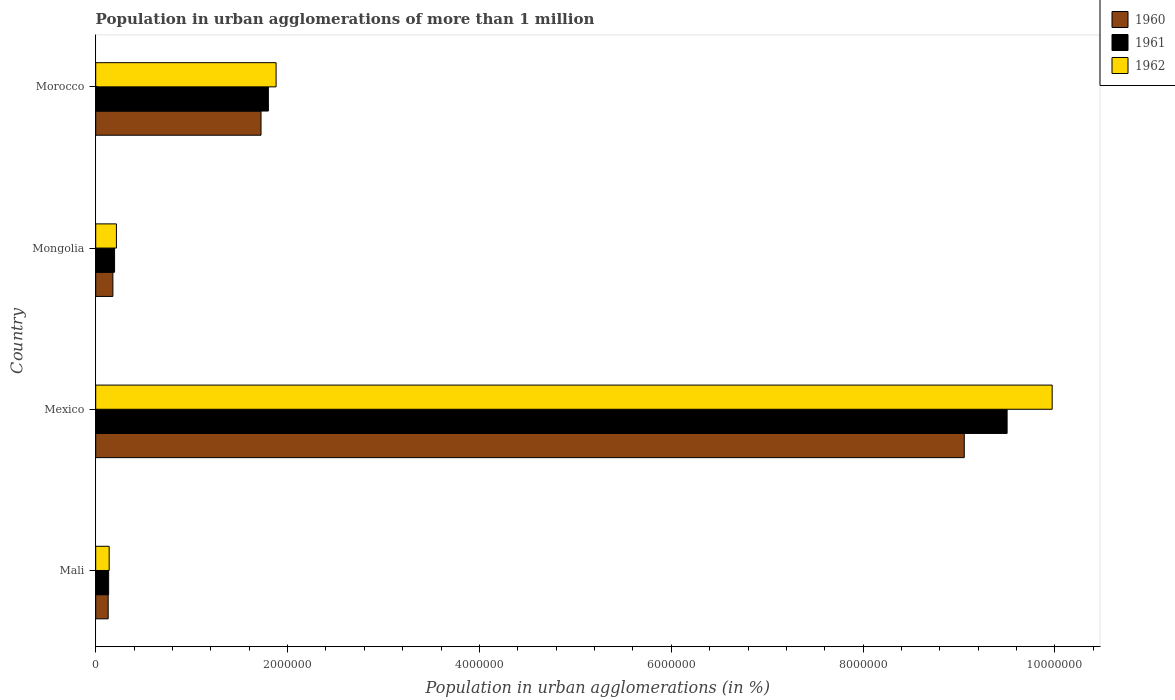How many different coloured bars are there?
Offer a very short reply. 3. How many groups of bars are there?
Your response must be concise. 4. How many bars are there on the 2nd tick from the top?
Offer a terse response. 3. How many bars are there on the 4th tick from the bottom?
Your answer should be very brief. 3. What is the label of the 1st group of bars from the top?
Offer a terse response. Morocco. In how many cases, is the number of bars for a given country not equal to the number of legend labels?
Your answer should be very brief. 0. What is the population in urban agglomerations in 1960 in Mexico?
Offer a terse response. 9.05e+06. Across all countries, what is the maximum population in urban agglomerations in 1960?
Offer a very short reply. 9.05e+06. Across all countries, what is the minimum population in urban agglomerations in 1962?
Your answer should be compact. 1.40e+05. In which country was the population in urban agglomerations in 1962 minimum?
Your response must be concise. Mali. What is the total population in urban agglomerations in 1961 in the graph?
Provide a succinct answer. 1.16e+07. What is the difference between the population in urban agglomerations in 1960 in Mexico and that in Mongolia?
Offer a terse response. 8.88e+06. What is the difference between the population in urban agglomerations in 1962 in Mongolia and the population in urban agglomerations in 1960 in Morocco?
Offer a very short reply. -1.51e+06. What is the average population in urban agglomerations in 1962 per country?
Your answer should be very brief. 3.05e+06. What is the difference between the population in urban agglomerations in 1961 and population in urban agglomerations in 1962 in Mexico?
Offer a terse response. -4.70e+05. What is the ratio of the population in urban agglomerations in 1961 in Mali to that in Mongolia?
Your answer should be compact. 0.69. What is the difference between the highest and the second highest population in urban agglomerations in 1962?
Provide a short and direct response. 8.09e+06. What is the difference between the highest and the lowest population in urban agglomerations in 1962?
Make the answer very short. 9.83e+06. What does the 2nd bar from the top in Mexico represents?
Your answer should be very brief. 1961. Is it the case that in every country, the sum of the population in urban agglomerations in 1961 and population in urban agglomerations in 1960 is greater than the population in urban agglomerations in 1962?
Provide a succinct answer. Yes. How many bars are there?
Your answer should be compact. 12. Are all the bars in the graph horizontal?
Offer a terse response. Yes. How many countries are there in the graph?
Provide a short and direct response. 4. Does the graph contain grids?
Provide a succinct answer. No. Where does the legend appear in the graph?
Your answer should be very brief. Top right. How are the legend labels stacked?
Provide a succinct answer. Vertical. What is the title of the graph?
Provide a succinct answer. Population in urban agglomerations of more than 1 million. Does "2010" appear as one of the legend labels in the graph?
Your answer should be compact. No. What is the label or title of the X-axis?
Give a very brief answer. Population in urban agglomerations (in %). What is the label or title of the Y-axis?
Keep it short and to the point. Country. What is the Population in urban agglomerations (in %) of 1960 in Mali?
Provide a short and direct response. 1.30e+05. What is the Population in urban agglomerations (in %) of 1961 in Mali?
Make the answer very short. 1.35e+05. What is the Population in urban agglomerations (in %) in 1962 in Mali?
Provide a short and direct response. 1.40e+05. What is the Population in urban agglomerations (in %) in 1960 in Mexico?
Your answer should be compact. 9.05e+06. What is the Population in urban agglomerations (in %) of 1961 in Mexico?
Keep it short and to the point. 9.50e+06. What is the Population in urban agglomerations (in %) of 1962 in Mexico?
Your answer should be very brief. 9.97e+06. What is the Population in urban agglomerations (in %) in 1960 in Mongolia?
Offer a terse response. 1.79e+05. What is the Population in urban agglomerations (in %) of 1961 in Mongolia?
Your answer should be very brief. 1.97e+05. What is the Population in urban agglomerations (in %) of 1962 in Mongolia?
Offer a terse response. 2.16e+05. What is the Population in urban agglomerations (in %) in 1960 in Morocco?
Make the answer very short. 1.72e+06. What is the Population in urban agglomerations (in %) of 1961 in Morocco?
Provide a succinct answer. 1.80e+06. What is the Population in urban agglomerations (in %) of 1962 in Morocco?
Make the answer very short. 1.88e+06. Across all countries, what is the maximum Population in urban agglomerations (in %) of 1960?
Your answer should be compact. 9.05e+06. Across all countries, what is the maximum Population in urban agglomerations (in %) of 1961?
Give a very brief answer. 9.50e+06. Across all countries, what is the maximum Population in urban agglomerations (in %) of 1962?
Provide a short and direct response. 9.97e+06. Across all countries, what is the minimum Population in urban agglomerations (in %) of 1960?
Offer a very short reply. 1.30e+05. Across all countries, what is the minimum Population in urban agglomerations (in %) in 1961?
Make the answer very short. 1.35e+05. Across all countries, what is the minimum Population in urban agglomerations (in %) in 1962?
Offer a terse response. 1.40e+05. What is the total Population in urban agglomerations (in %) in 1960 in the graph?
Your answer should be very brief. 1.11e+07. What is the total Population in urban agglomerations (in %) in 1961 in the graph?
Keep it short and to the point. 1.16e+07. What is the total Population in urban agglomerations (in %) in 1962 in the graph?
Offer a terse response. 1.22e+07. What is the difference between the Population in urban agglomerations (in %) in 1960 in Mali and that in Mexico?
Offer a terse response. -8.92e+06. What is the difference between the Population in urban agglomerations (in %) in 1961 in Mali and that in Mexico?
Offer a terse response. -9.37e+06. What is the difference between the Population in urban agglomerations (in %) of 1962 in Mali and that in Mexico?
Provide a succinct answer. -9.83e+06. What is the difference between the Population in urban agglomerations (in %) of 1960 in Mali and that in Mongolia?
Offer a terse response. -4.90e+04. What is the difference between the Population in urban agglomerations (in %) in 1961 in Mali and that in Mongolia?
Your answer should be very brief. -6.19e+04. What is the difference between the Population in urban agglomerations (in %) in 1962 in Mali and that in Mongolia?
Offer a very short reply. -7.58e+04. What is the difference between the Population in urban agglomerations (in %) in 1960 in Mali and that in Morocco?
Provide a succinct answer. -1.59e+06. What is the difference between the Population in urban agglomerations (in %) of 1961 in Mali and that in Morocco?
Make the answer very short. -1.67e+06. What is the difference between the Population in urban agglomerations (in %) in 1962 in Mali and that in Morocco?
Give a very brief answer. -1.74e+06. What is the difference between the Population in urban agglomerations (in %) in 1960 in Mexico and that in Mongolia?
Provide a succinct answer. 8.88e+06. What is the difference between the Population in urban agglomerations (in %) in 1961 in Mexico and that in Mongolia?
Your answer should be compact. 9.30e+06. What is the difference between the Population in urban agglomerations (in %) in 1962 in Mexico and that in Mongolia?
Give a very brief answer. 9.75e+06. What is the difference between the Population in urban agglomerations (in %) of 1960 in Mexico and that in Morocco?
Offer a terse response. 7.33e+06. What is the difference between the Population in urban agglomerations (in %) of 1961 in Mexico and that in Morocco?
Provide a succinct answer. 7.70e+06. What is the difference between the Population in urban agglomerations (in %) in 1962 in Mexico and that in Morocco?
Your response must be concise. 8.09e+06. What is the difference between the Population in urban agglomerations (in %) of 1960 in Mongolia and that in Morocco?
Your answer should be very brief. -1.54e+06. What is the difference between the Population in urban agglomerations (in %) in 1961 in Mongolia and that in Morocco?
Your answer should be compact. -1.60e+06. What is the difference between the Population in urban agglomerations (in %) in 1962 in Mongolia and that in Morocco?
Give a very brief answer. -1.66e+06. What is the difference between the Population in urban agglomerations (in %) in 1960 in Mali and the Population in urban agglomerations (in %) in 1961 in Mexico?
Give a very brief answer. -9.37e+06. What is the difference between the Population in urban agglomerations (in %) in 1960 in Mali and the Population in urban agglomerations (in %) in 1962 in Mexico?
Keep it short and to the point. -9.84e+06. What is the difference between the Population in urban agglomerations (in %) in 1961 in Mali and the Population in urban agglomerations (in %) in 1962 in Mexico?
Provide a short and direct response. -9.84e+06. What is the difference between the Population in urban agglomerations (in %) in 1960 in Mali and the Population in urban agglomerations (in %) in 1961 in Mongolia?
Provide a short and direct response. -6.67e+04. What is the difference between the Population in urban agglomerations (in %) of 1960 in Mali and the Population in urban agglomerations (in %) of 1962 in Mongolia?
Your answer should be very brief. -8.60e+04. What is the difference between the Population in urban agglomerations (in %) of 1961 in Mali and the Population in urban agglomerations (in %) of 1962 in Mongolia?
Offer a very short reply. -8.13e+04. What is the difference between the Population in urban agglomerations (in %) of 1960 in Mali and the Population in urban agglomerations (in %) of 1961 in Morocco?
Keep it short and to the point. -1.67e+06. What is the difference between the Population in urban agglomerations (in %) in 1960 in Mali and the Population in urban agglomerations (in %) in 1962 in Morocco?
Keep it short and to the point. -1.75e+06. What is the difference between the Population in urban agglomerations (in %) in 1961 in Mali and the Population in urban agglomerations (in %) in 1962 in Morocco?
Offer a terse response. -1.75e+06. What is the difference between the Population in urban agglomerations (in %) in 1960 in Mexico and the Population in urban agglomerations (in %) in 1961 in Mongolia?
Give a very brief answer. 8.86e+06. What is the difference between the Population in urban agglomerations (in %) in 1960 in Mexico and the Population in urban agglomerations (in %) in 1962 in Mongolia?
Your answer should be very brief. 8.84e+06. What is the difference between the Population in urban agglomerations (in %) in 1961 in Mexico and the Population in urban agglomerations (in %) in 1962 in Mongolia?
Offer a very short reply. 9.28e+06. What is the difference between the Population in urban agglomerations (in %) in 1960 in Mexico and the Population in urban agglomerations (in %) in 1961 in Morocco?
Keep it short and to the point. 7.25e+06. What is the difference between the Population in urban agglomerations (in %) in 1960 in Mexico and the Population in urban agglomerations (in %) in 1962 in Morocco?
Make the answer very short. 7.17e+06. What is the difference between the Population in urban agglomerations (in %) of 1961 in Mexico and the Population in urban agglomerations (in %) of 1962 in Morocco?
Your response must be concise. 7.62e+06. What is the difference between the Population in urban agglomerations (in %) in 1960 in Mongolia and the Population in urban agglomerations (in %) in 1961 in Morocco?
Offer a terse response. -1.62e+06. What is the difference between the Population in urban agglomerations (in %) of 1960 in Mongolia and the Population in urban agglomerations (in %) of 1962 in Morocco?
Ensure brevity in your answer.  -1.70e+06. What is the difference between the Population in urban agglomerations (in %) in 1961 in Mongolia and the Population in urban agglomerations (in %) in 1962 in Morocco?
Keep it short and to the point. -1.68e+06. What is the average Population in urban agglomerations (in %) of 1960 per country?
Your answer should be compact. 2.77e+06. What is the average Population in urban agglomerations (in %) of 1961 per country?
Give a very brief answer. 2.91e+06. What is the average Population in urban agglomerations (in %) of 1962 per country?
Your answer should be compact. 3.05e+06. What is the difference between the Population in urban agglomerations (in %) in 1960 and Population in urban agglomerations (in %) in 1961 in Mali?
Your answer should be very brief. -4767. What is the difference between the Population in urban agglomerations (in %) of 1960 and Population in urban agglomerations (in %) of 1962 in Mali?
Offer a terse response. -1.02e+04. What is the difference between the Population in urban agglomerations (in %) in 1961 and Population in urban agglomerations (in %) in 1962 in Mali?
Give a very brief answer. -5483. What is the difference between the Population in urban agglomerations (in %) in 1960 and Population in urban agglomerations (in %) in 1961 in Mexico?
Give a very brief answer. -4.46e+05. What is the difference between the Population in urban agglomerations (in %) in 1960 and Population in urban agglomerations (in %) in 1962 in Mexico?
Offer a very short reply. -9.16e+05. What is the difference between the Population in urban agglomerations (in %) of 1961 and Population in urban agglomerations (in %) of 1962 in Mexico?
Ensure brevity in your answer.  -4.70e+05. What is the difference between the Population in urban agglomerations (in %) in 1960 and Population in urban agglomerations (in %) in 1961 in Mongolia?
Provide a short and direct response. -1.76e+04. What is the difference between the Population in urban agglomerations (in %) in 1960 and Population in urban agglomerations (in %) in 1962 in Mongolia?
Keep it short and to the point. -3.70e+04. What is the difference between the Population in urban agglomerations (in %) of 1961 and Population in urban agglomerations (in %) of 1962 in Mongolia?
Offer a terse response. -1.94e+04. What is the difference between the Population in urban agglomerations (in %) in 1960 and Population in urban agglomerations (in %) in 1961 in Morocco?
Offer a very short reply. -7.66e+04. What is the difference between the Population in urban agglomerations (in %) of 1960 and Population in urban agglomerations (in %) of 1962 in Morocco?
Provide a short and direct response. -1.57e+05. What is the difference between the Population in urban agglomerations (in %) in 1961 and Population in urban agglomerations (in %) in 1962 in Morocco?
Your answer should be very brief. -8.05e+04. What is the ratio of the Population in urban agglomerations (in %) of 1960 in Mali to that in Mexico?
Give a very brief answer. 0.01. What is the ratio of the Population in urban agglomerations (in %) in 1961 in Mali to that in Mexico?
Provide a succinct answer. 0.01. What is the ratio of the Population in urban agglomerations (in %) in 1962 in Mali to that in Mexico?
Ensure brevity in your answer.  0.01. What is the ratio of the Population in urban agglomerations (in %) in 1960 in Mali to that in Mongolia?
Your response must be concise. 0.73. What is the ratio of the Population in urban agglomerations (in %) of 1961 in Mali to that in Mongolia?
Provide a succinct answer. 0.69. What is the ratio of the Population in urban agglomerations (in %) of 1962 in Mali to that in Mongolia?
Make the answer very short. 0.65. What is the ratio of the Population in urban agglomerations (in %) in 1960 in Mali to that in Morocco?
Your response must be concise. 0.08. What is the ratio of the Population in urban agglomerations (in %) in 1961 in Mali to that in Morocco?
Your response must be concise. 0.07. What is the ratio of the Population in urban agglomerations (in %) in 1962 in Mali to that in Morocco?
Offer a very short reply. 0.07. What is the ratio of the Population in urban agglomerations (in %) of 1960 in Mexico to that in Mongolia?
Keep it short and to the point. 50.57. What is the ratio of the Population in urban agglomerations (in %) of 1961 in Mexico to that in Mongolia?
Your answer should be very brief. 48.31. What is the ratio of the Population in urban agglomerations (in %) in 1962 in Mexico to that in Mongolia?
Your answer should be compact. 46.15. What is the ratio of the Population in urban agglomerations (in %) in 1960 in Mexico to that in Morocco?
Provide a succinct answer. 5.25. What is the ratio of the Population in urban agglomerations (in %) of 1961 in Mexico to that in Morocco?
Offer a terse response. 5.28. What is the ratio of the Population in urban agglomerations (in %) of 1962 in Mexico to that in Morocco?
Offer a very short reply. 5.3. What is the ratio of the Population in urban agglomerations (in %) of 1960 in Mongolia to that in Morocco?
Ensure brevity in your answer.  0.1. What is the ratio of the Population in urban agglomerations (in %) of 1961 in Mongolia to that in Morocco?
Keep it short and to the point. 0.11. What is the ratio of the Population in urban agglomerations (in %) of 1962 in Mongolia to that in Morocco?
Offer a terse response. 0.11. What is the difference between the highest and the second highest Population in urban agglomerations (in %) in 1960?
Offer a very short reply. 7.33e+06. What is the difference between the highest and the second highest Population in urban agglomerations (in %) of 1961?
Provide a succinct answer. 7.70e+06. What is the difference between the highest and the second highest Population in urban agglomerations (in %) in 1962?
Your answer should be compact. 8.09e+06. What is the difference between the highest and the lowest Population in urban agglomerations (in %) in 1960?
Give a very brief answer. 8.92e+06. What is the difference between the highest and the lowest Population in urban agglomerations (in %) in 1961?
Make the answer very short. 9.37e+06. What is the difference between the highest and the lowest Population in urban agglomerations (in %) in 1962?
Provide a short and direct response. 9.83e+06. 